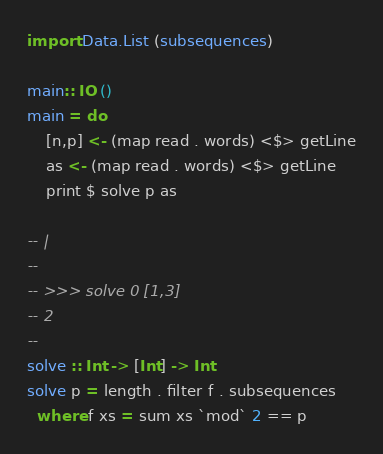<code> <loc_0><loc_0><loc_500><loc_500><_Haskell_>import Data.List (subsequences)

main:: IO ()
main = do
    [n,p] <- (map read . words) <$> getLine
    as <- (map read . words) <$> getLine
    print $ solve p as

-- |
--
-- >>> solve 0 [1,3]
-- 2
--
solve :: Int -> [Int] -> Int
solve p = length . filter f . subsequences
  where f xs = sum xs `mod` 2 == p

</code> 